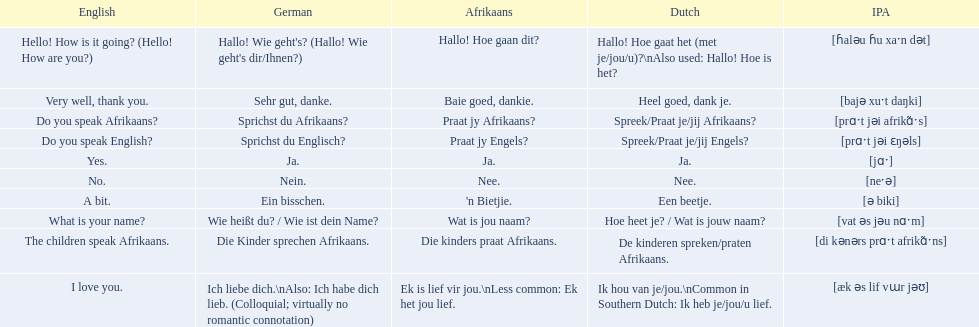What are all of the afrikaans phrases in the list? Hallo! Hoe gaan dit?, Baie goed, dankie., Praat jy Afrikaans?, Praat jy Engels?, Ja., Nee., 'n Bietjie., Wat is jou naam?, Die kinders praat Afrikaans., Ek is lief vir jou.\nLess common: Ek het jou lief. What is the english translation of each phrase? Hello! How is it going? (Hello! How are you?), Very well, thank you., Do you speak Afrikaans?, Do you speak English?, Yes., No., A bit., What is your name?, The children speak Afrikaans., I love you. And which afrikaans phrase translated to do you speak afrikaans? Praat jy Afrikaans?. 